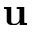<formula> <loc_0><loc_0><loc_500><loc_500>u</formula> 